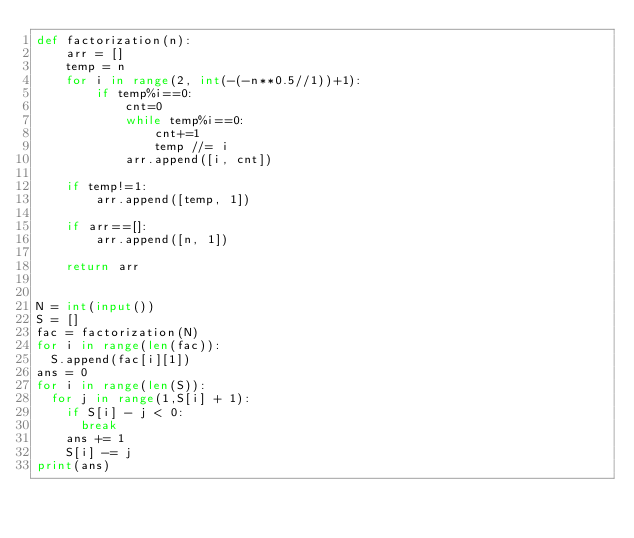<code> <loc_0><loc_0><loc_500><loc_500><_Python_>def factorization(n):
    arr = []
    temp = n
    for i in range(2, int(-(-n**0.5//1))+1):
        if temp%i==0:
            cnt=0
            while temp%i==0:
                cnt+=1
                temp //= i
            arr.append([i, cnt])

    if temp!=1:
        arr.append([temp, 1])

    if arr==[]:
        arr.append([n, 1])

    return arr
  

N = int(input())
S = []
fac = factorization(N)
for i in range(len(fac)):
  S.append(fac[i][1])
ans = 0
for i in range(len(S)):
  for j in range(1,S[i] + 1):
    if S[i] - j < 0:
      break
    ans += 1
    S[i] -= j
print(ans)</code> 